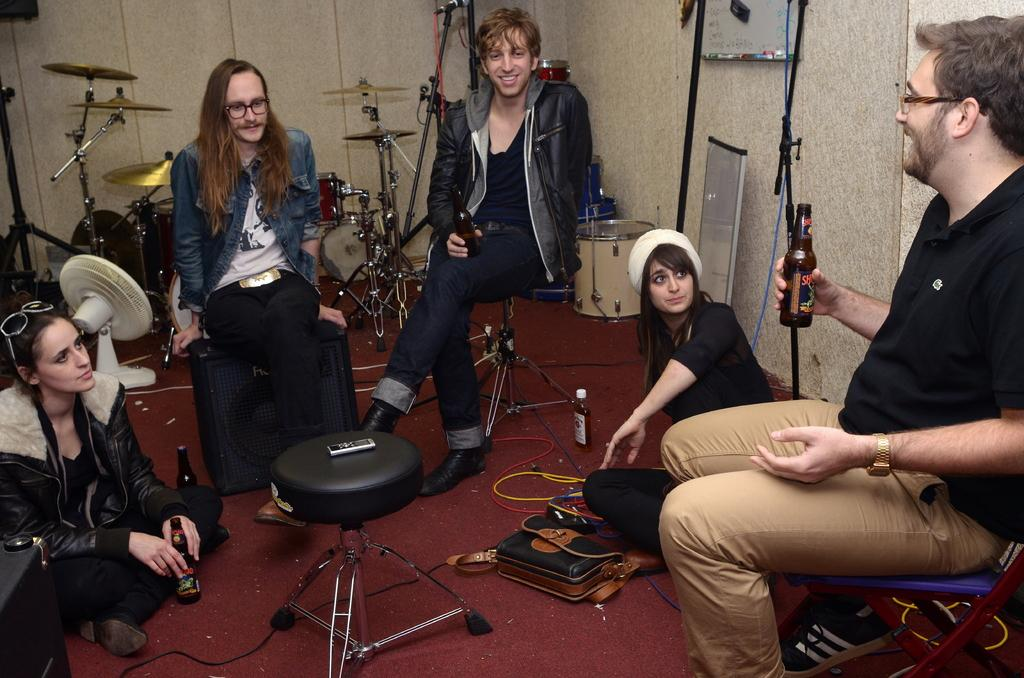How many people are seated in the room? There are five people seated in the room. What can be found in the room besides the people? There are musical instruments, a fan, a bottle, bags, and a notice board in the room. What might be used for playing music in the room? Musical instruments are present in the room. What might be used for displaying information or announcements in the room? There is a notice board in the room. How many frogs are sitting on the musical instruments in the room? There is no mention of frogs in the image, so we cannot determine the number of frogs on the musical instruments. What type of bird can be seen perched on the fan in the room? There is no bird, specifically a wren, present in the image. 